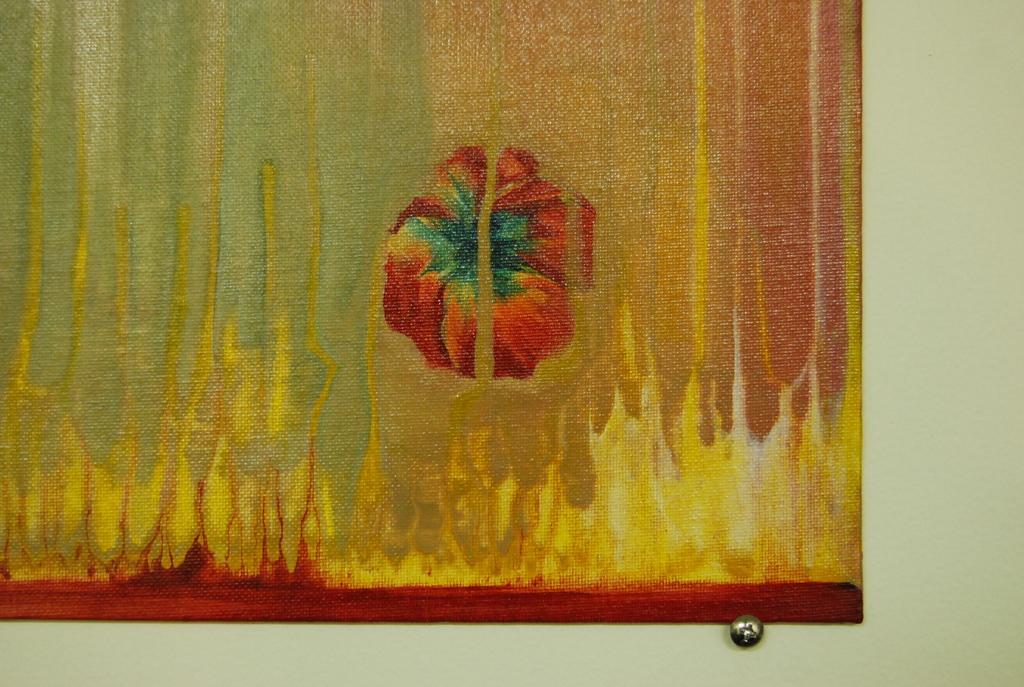Could you give a brief overview of what you see in this image? There is a painting on the wall in the image. 